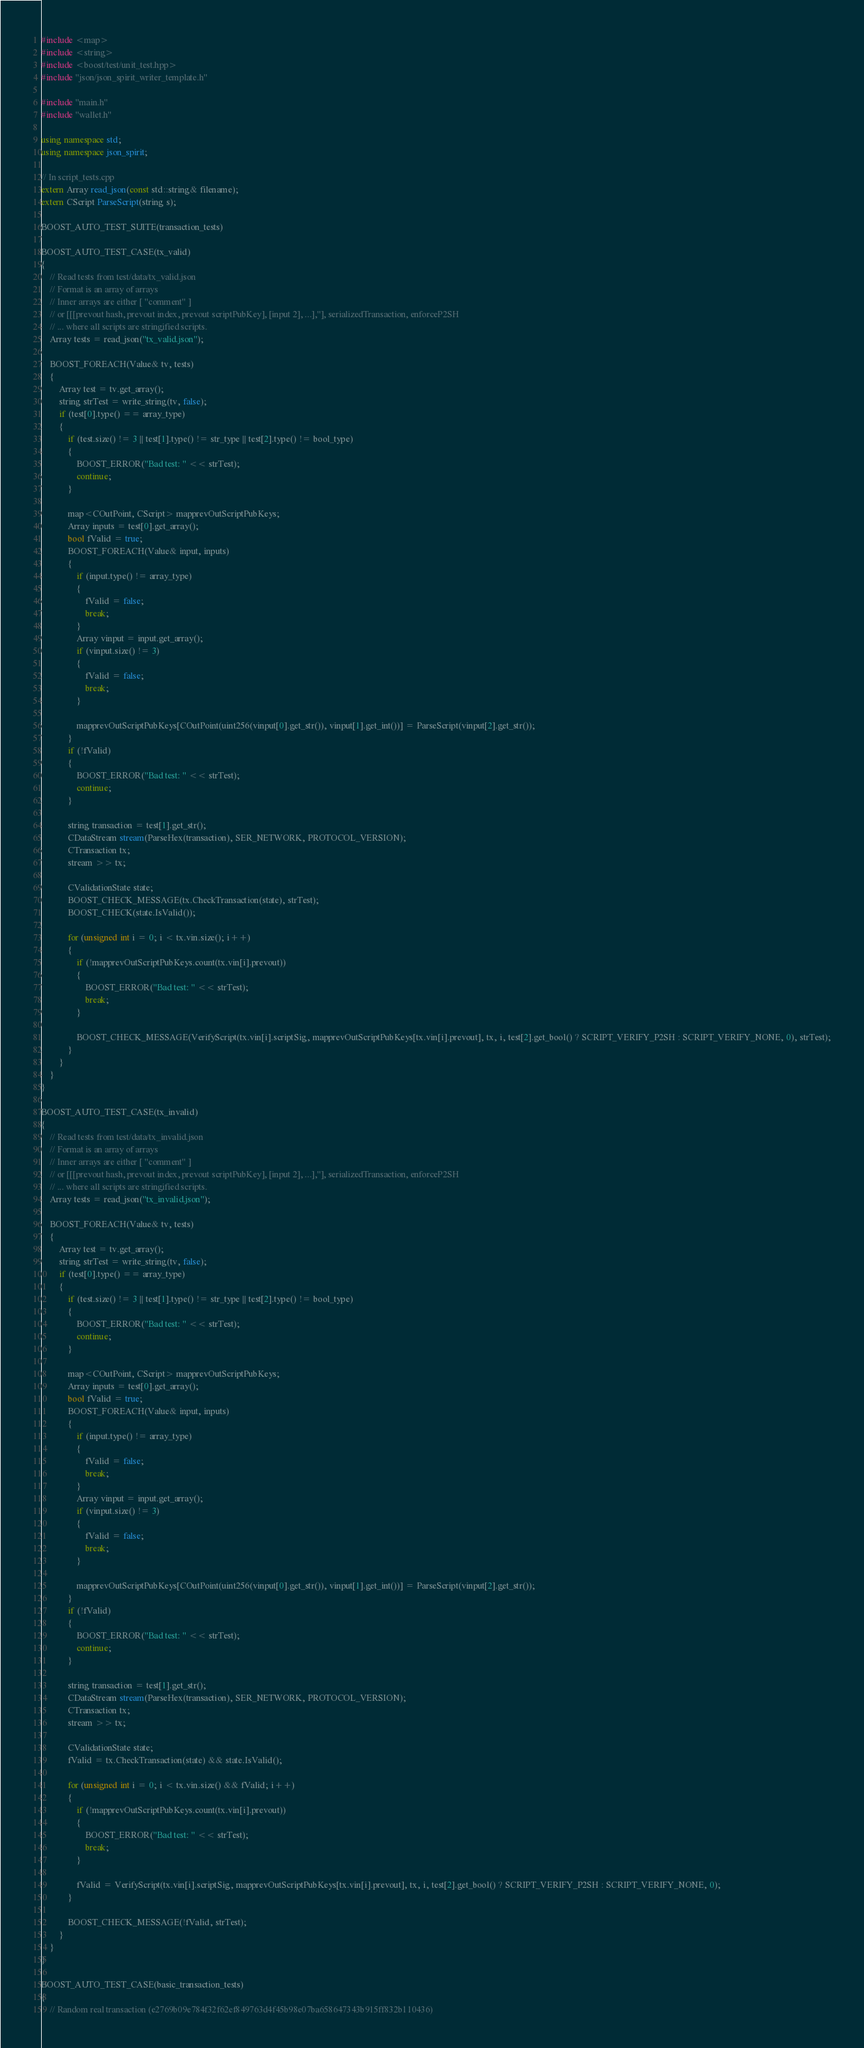Convert code to text. <code><loc_0><loc_0><loc_500><loc_500><_C++_>#include <map>
#include <string>
#include <boost/test/unit_test.hpp>
#include "json/json_spirit_writer_template.h"

#include "main.h"
#include "wallet.h"

using namespace std;
using namespace json_spirit;

// In script_tests.cpp
extern Array read_json(const std::string& filename);
extern CScript ParseScript(string s);

BOOST_AUTO_TEST_SUITE(transaction_tests)

BOOST_AUTO_TEST_CASE(tx_valid)
{
    // Read tests from test/data/tx_valid.json
    // Format is an array of arrays
    // Inner arrays are either [ "comment" ]
    // or [[[prevout hash, prevout index, prevout scriptPubKey], [input 2], ...],"], serializedTransaction, enforceP2SH
    // ... where all scripts are stringified scripts.
    Array tests = read_json("tx_valid.json");

    BOOST_FOREACH(Value& tv, tests)
    {
        Array test = tv.get_array();
        string strTest = write_string(tv, false);
        if (test[0].type() == array_type)
        {
            if (test.size() != 3 || test[1].type() != str_type || test[2].type() != bool_type)
            {
                BOOST_ERROR("Bad test: " << strTest);
                continue;
            }

            map<COutPoint, CScript> mapprevOutScriptPubKeys;
            Array inputs = test[0].get_array();
            bool fValid = true;
            BOOST_FOREACH(Value& input, inputs)
            {
                if (input.type() != array_type)
                {
                    fValid = false;
                    break;
                }
                Array vinput = input.get_array();
                if (vinput.size() != 3)
                {
                    fValid = false;
                    break;
                }

                mapprevOutScriptPubKeys[COutPoint(uint256(vinput[0].get_str()), vinput[1].get_int())] = ParseScript(vinput[2].get_str());
            }
            if (!fValid)
            {
                BOOST_ERROR("Bad test: " << strTest);
                continue;
            }

            string transaction = test[1].get_str();
            CDataStream stream(ParseHex(transaction), SER_NETWORK, PROTOCOL_VERSION);
            CTransaction tx;
            stream >> tx;

            CValidationState state;
            BOOST_CHECK_MESSAGE(tx.CheckTransaction(state), strTest);
            BOOST_CHECK(state.IsValid());

            for (unsigned int i = 0; i < tx.vin.size(); i++)
            {
                if (!mapprevOutScriptPubKeys.count(tx.vin[i].prevout))
                {
                    BOOST_ERROR("Bad test: " << strTest);
                    break;
                }

                BOOST_CHECK_MESSAGE(VerifyScript(tx.vin[i].scriptSig, mapprevOutScriptPubKeys[tx.vin[i].prevout], tx, i, test[2].get_bool() ? SCRIPT_VERIFY_P2SH : SCRIPT_VERIFY_NONE, 0), strTest);
            }
        }
    }
}

BOOST_AUTO_TEST_CASE(tx_invalid)
{
    // Read tests from test/data/tx_invalid.json
    // Format is an array of arrays
    // Inner arrays are either [ "comment" ]
    // or [[[prevout hash, prevout index, prevout scriptPubKey], [input 2], ...],"], serializedTransaction, enforceP2SH
    // ... where all scripts are stringified scripts.
    Array tests = read_json("tx_invalid.json");

    BOOST_FOREACH(Value& tv, tests)
    {
        Array test = tv.get_array();
        string strTest = write_string(tv, false);
        if (test[0].type() == array_type)
        {
            if (test.size() != 3 || test[1].type() != str_type || test[2].type() != bool_type)
            {
                BOOST_ERROR("Bad test: " << strTest);
                continue;
            }

            map<COutPoint, CScript> mapprevOutScriptPubKeys;
            Array inputs = test[0].get_array();
            bool fValid = true;
            BOOST_FOREACH(Value& input, inputs)
            {
                if (input.type() != array_type)
                {
                    fValid = false;
                    break;
                }
                Array vinput = input.get_array();
                if (vinput.size() != 3)
                {
                    fValid = false;
                    break;
                }

                mapprevOutScriptPubKeys[COutPoint(uint256(vinput[0].get_str()), vinput[1].get_int())] = ParseScript(vinput[2].get_str());
            }
            if (!fValid)
            {
                BOOST_ERROR("Bad test: " << strTest);
                continue;
            }

            string transaction = test[1].get_str();
            CDataStream stream(ParseHex(transaction), SER_NETWORK, PROTOCOL_VERSION);
            CTransaction tx;
            stream >> tx;

            CValidationState state;
            fValid = tx.CheckTransaction(state) && state.IsValid();

            for (unsigned int i = 0; i < tx.vin.size() && fValid; i++)
            {
                if (!mapprevOutScriptPubKeys.count(tx.vin[i].prevout))
                {
                    BOOST_ERROR("Bad test: " << strTest);
                    break;
                }

                fValid = VerifyScript(tx.vin[i].scriptSig, mapprevOutScriptPubKeys[tx.vin[i].prevout], tx, i, test[2].get_bool() ? SCRIPT_VERIFY_P2SH : SCRIPT_VERIFY_NONE, 0);
            }

            BOOST_CHECK_MESSAGE(!fValid, strTest);
        }
    }
}

BOOST_AUTO_TEST_CASE(basic_transaction_tests)
{
    // Random real transaction (e2769b09e784f32f62ef849763d4f45b98e07ba658647343b915ff832b110436)</code> 